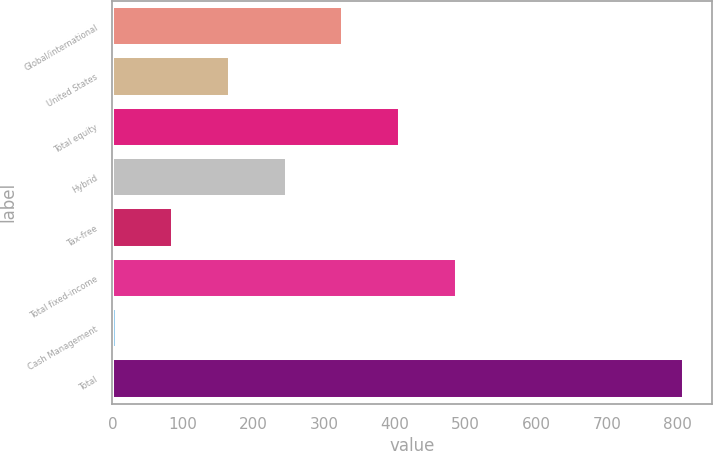Convert chart. <chart><loc_0><loc_0><loc_500><loc_500><bar_chart><fcel>Global/international<fcel>United States<fcel>Total equity<fcel>Hybrid<fcel>Tax-free<fcel>Total fixed-income<fcel>Cash Management<fcel>Total<nl><fcel>326.88<fcel>166.44<fcel>407.1<fcel>246.66<fcel>86.22<fcel>487.32<fcel>6<fcel>808.2<nl></chart> 